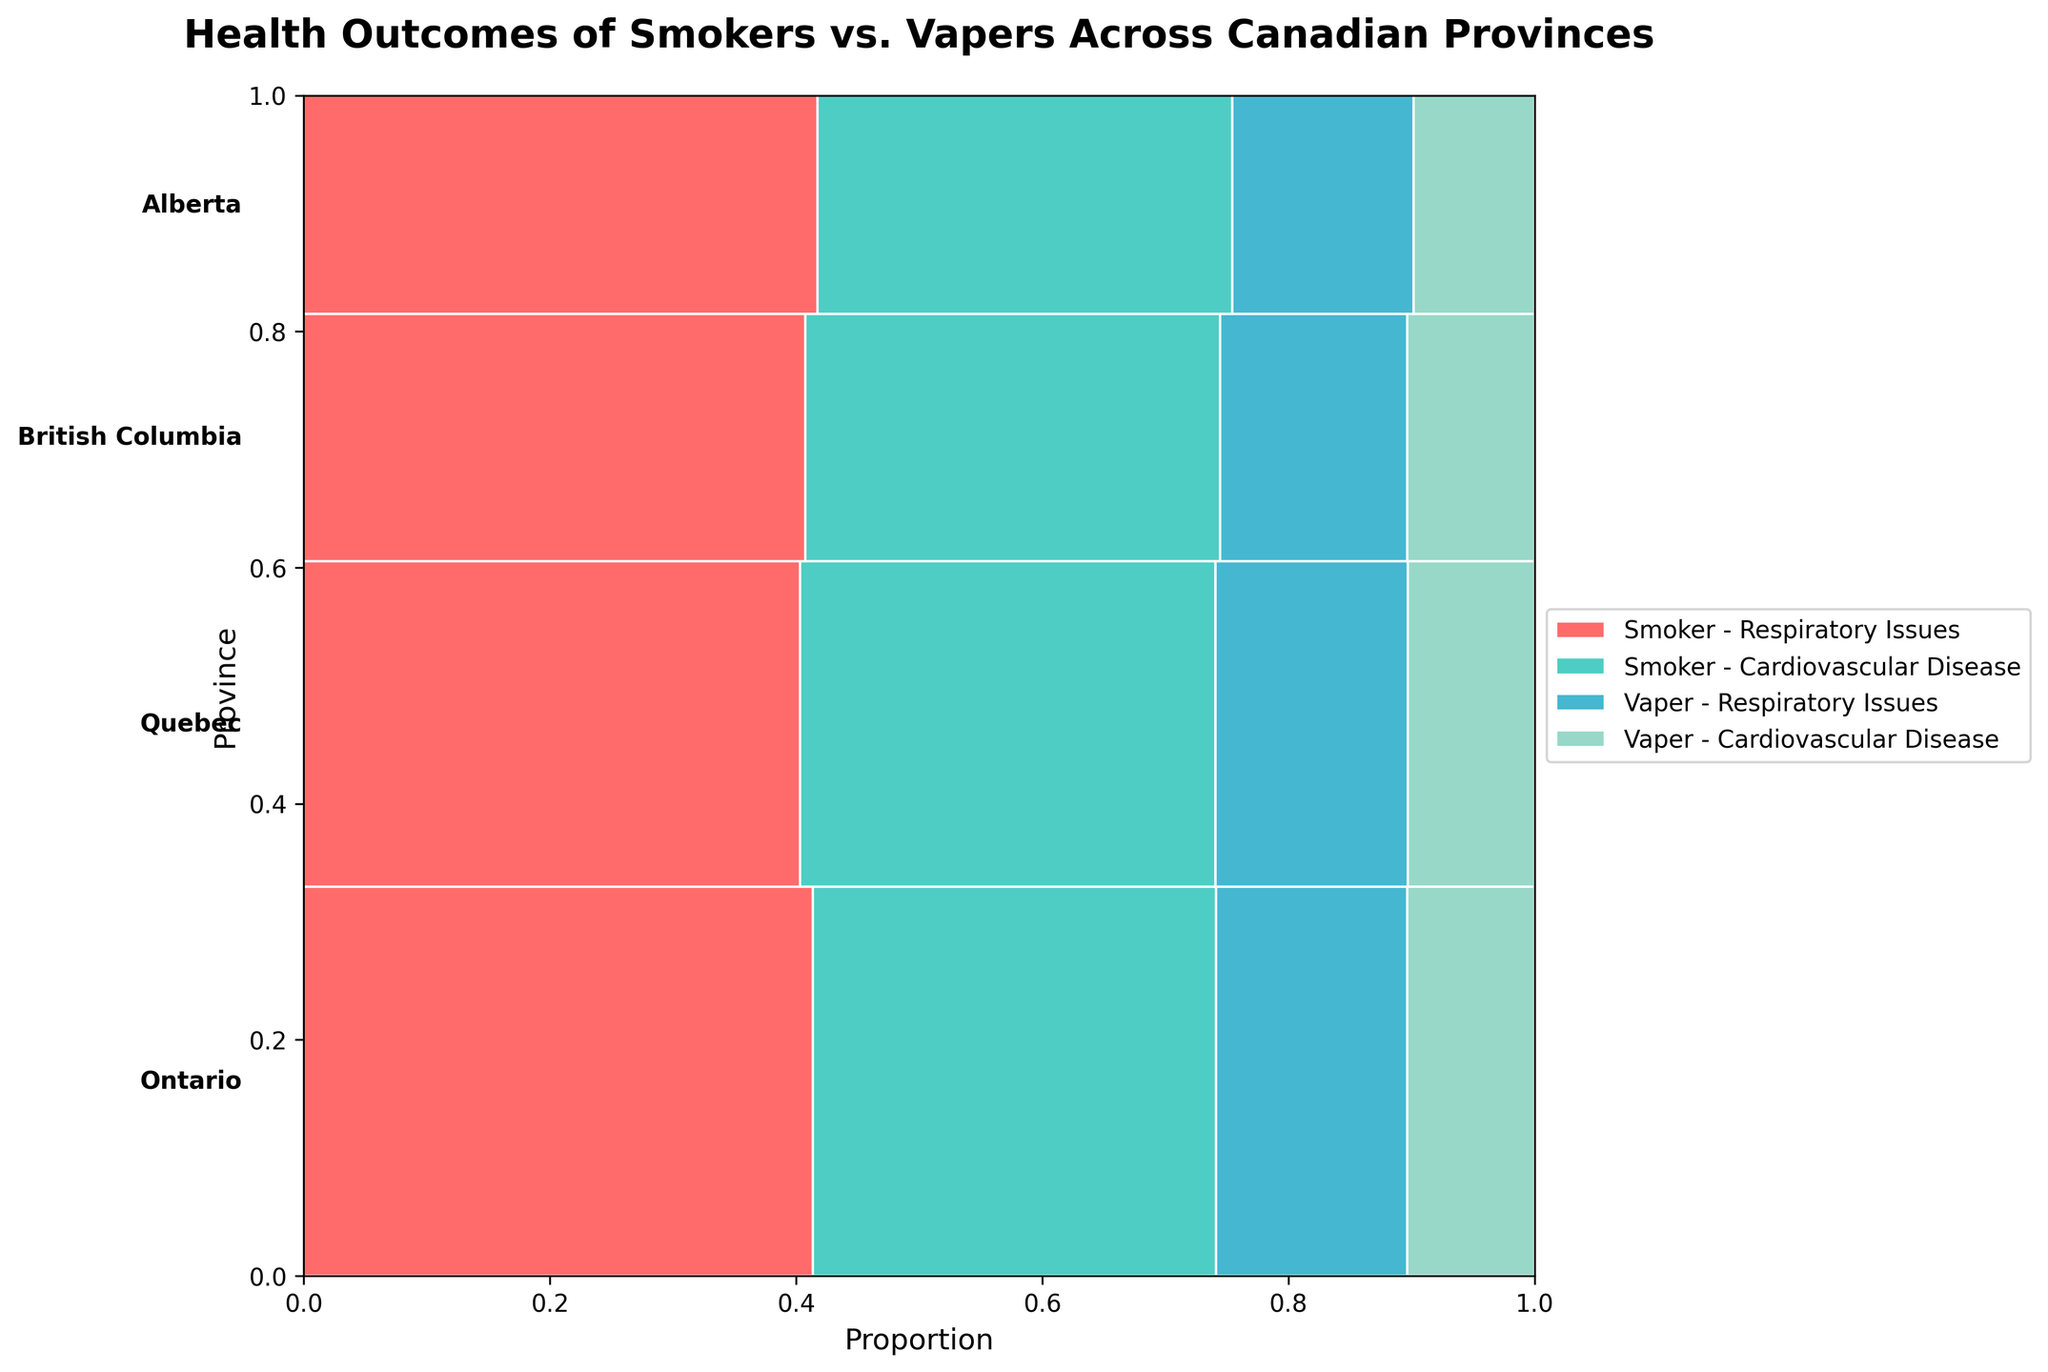What is the title of the plot? The title of the plot is written at the top of the figure.
Answer: Health Outcomes of Smokers vs. Vapers Across Canadian Provinces Which health outcome has the largest area for smokers in Ontario? The largest area for a health outcome among smokers in Ontario can be identified by comparing the widths of the rectangles under the "Smoker" category within the "Ontario" section.
Answer: Respiratory Issues How does the proportion of vapers with respiratory issues compare between Quebec and British Columbia? Compare the widths of the rectangles for the "Vaper" category with "Respiratory Issues" in Quebec and British Columbia sections.
Answer: Quebec has a higher proportion What is the total proportion of cardiovascular disease among vapers in Alberta? Locate the rectangle for "Cardiovascular Disease" under the "Vaper" category in Alberta and note its relative width to the total width of the "Alberta" section for vapers.
Answer: 40% Which province has the smallest proportion of smokers with cardiovascular disease? Compare the rectangles for "Cardiovascular Disease" under the "Smoker" category across all provinces.
Answer: Alberta Which health outcome among vapers has a larger proportion in Ontario compared to Quebec? Compare the rectangles for the two health outcomes under the "Vaper" category between Ontario and Quebec sections.
Answer: Respiratory Issues How do health outcomes for vapers in British Columbia compare with those in Quebec? Examine and compare the sizes of the rectangles for both health outcomes under the "Vaper" category in British Columbia and Quebec sections.
Answer: Quebec has higher proportions for both outcomes What is the combined proportion of respiratory issues for smokers and vapers in British Columbia compared to Alberta? Sum the widths of the rectangles for "Respiratory Issues" under both "Smoker" and "Vaper" categories in British Columbia and Alberta sections, then compare.
Answer: British Columbia has a higher combined proportion Between Ontario and Alberta, which province has a larger proportion of vapers with cardiovascular disease? Compare the rectangles for "Cardiovascular Disease" under the "Vaper" category between Ontario and Alberta sections.
Answer: Ontario In which province do smokers have a smaller proportion of cardiovascular disease compared to respiratory issues? Compare the sizes of the rectangles for "Cardiovascular Disease" and "Respiratory Issues" under the "Smoker" category within each province.
Answer: Ontario 